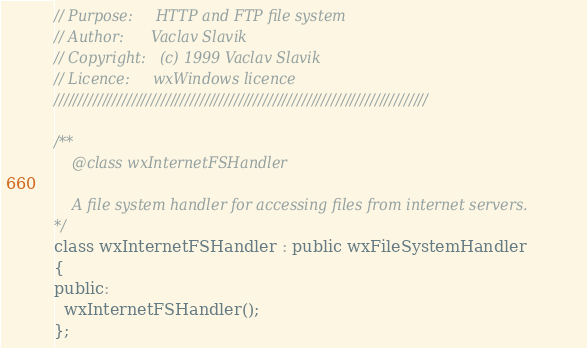<code> <loc_0><loc_0><loc_500><loc_500><_C_>// Purpose:     HTTP and FTP file system
// Author:      Vaclav Slavik
// Copyright:   (c) 1999 Vaclav Slavik
// Licence:     wxWindows licence
/////////////////////////////////////////////////////////////////////////////

/**
    @class wxInternetFSHandler

    A file system handler for accessing files from internet servers.
*/
class wxInternetFSHandler : public wxFileSystemHandler
{
public:
  wxInternetFSHandler();
};
</code> 